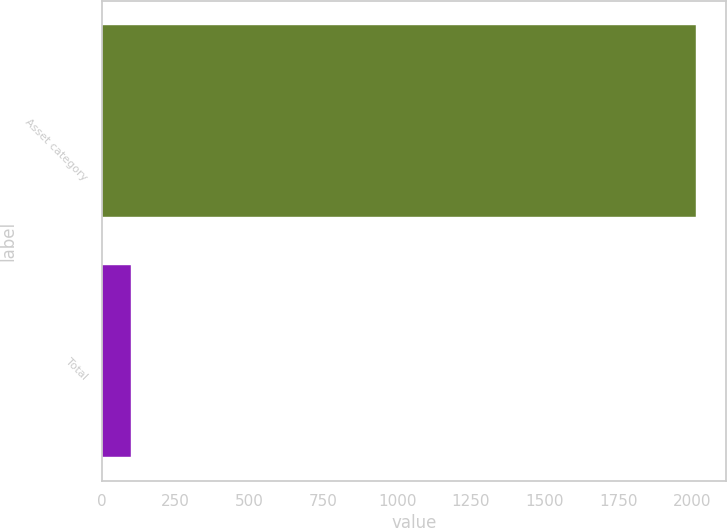Convert chart. <chart><loc_0><loc_0><loc_500><loc_500><bar_chart><fcel>Asset category<fcel>Total<nl><fcel>2013<fcel>100<nl></chart> 